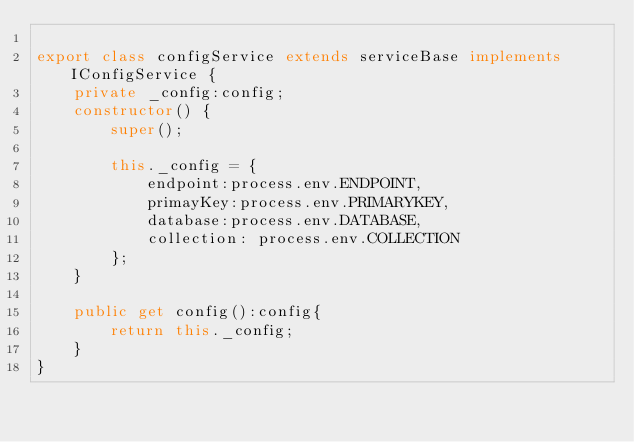Convert code to text. <code><loc_0><loc_0><loc_500><loc_500><_TypeScript_>
export class configService extends serviceBase implements IConfigService {
    private _config:config;
    constructor() {
        super();
        
        this._config = {
            endpoint:process.env.ENDPOINT,
            primayKey:process.env.PRIMARYKEY, 
            database:process.env.DATABASE,
            collection: process.env.COLLECTION
        };
    }

    public get config():config{
        return this._config;
    }
}</code> 